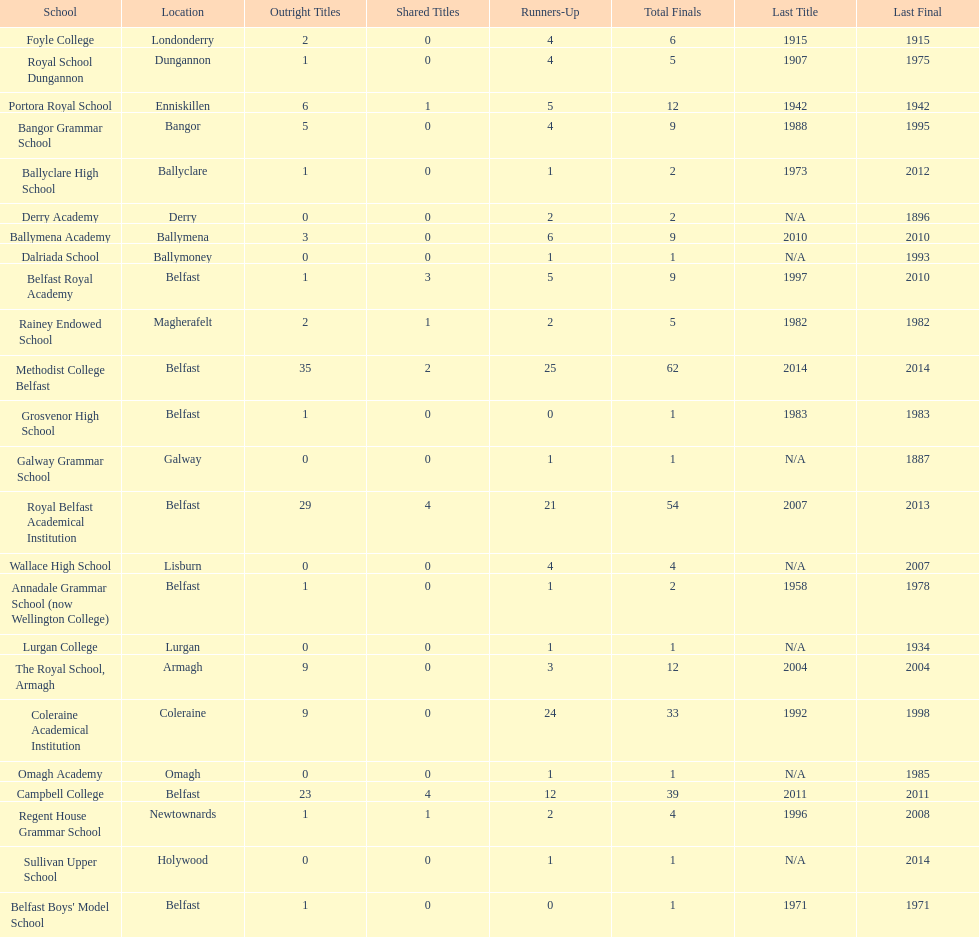What was the last year that the regent house grammar school won a title? 1996. 